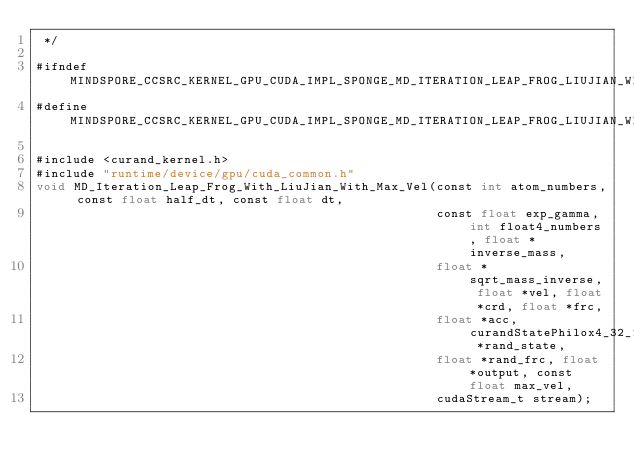<code> <loc_0><loc_0><loc_500><loc_500><_Cuda_> */

#ifndef MINDSPORE_CCSRC_KERNEL_GPU_CUDA_IMPL_SPONGE_MD_ITERATION_LEAP_FROG_LIUJIAN_WITH_MAX_VEL_IMPL_H_
#define MINDSPORE_CCSRC_KERNEL_GPU_CUDA_IMPL_SPONGE_MD_ITERATION_LEAP_FROG_LIUJIAN_WITH_MAX_VEL_IMPL_H_

#include <curand_kernel.h>
#include "runtime/device/gpu/cuda_common.h"
void MD_Iteration_Leap_Frog_With_LiuJian_With_Max_Vel(const int atom_numbers, const float half_dt, const float dt,
                                                      const float exp_gamma, int float4_numbers, float *inverse_mass,
                                                      float *sqrt_mass_inverse, float *vel, float *crd, float *frc,
                                                      float *acc, curandStatePhilox4_32_10_t *rand_state,
                                                      float *rand_frc, float *output, const float max_vel,
                                                      cudaStream_t stream);
</code> 